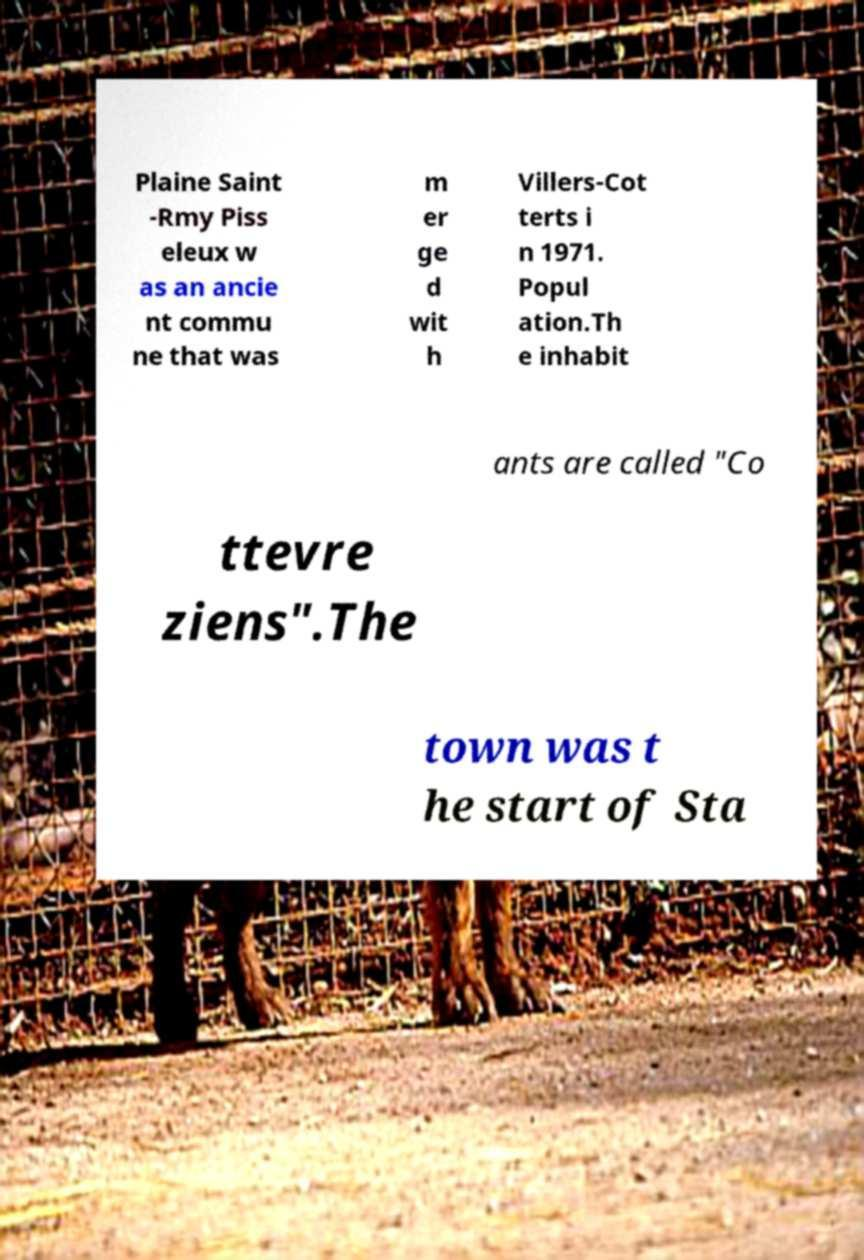Could you assist in decoding the text presented in this image and type it out clearly? Plaine Saint -Rmy Piss eleux w as an ancie nt commu ne that was m er ge d wit h Villers-Cot terts i n 1971. Popul ation.Th e inhabit ants are called "Co ttevre ziens".The town was t he start of Sta 